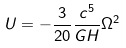<formula> <loc_0><loc_0><loc_500><loc_500>U = - \frac { 3 } { 2 0 } \frac { c ^ { 5 } } { G H } \Omega ^ { 2 }</formula> 